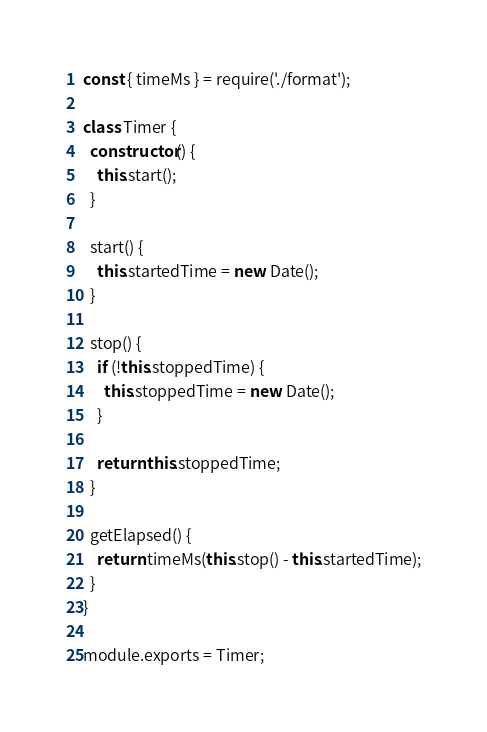Convert code to text. <code><loc_0><loc_0><loc_500><loc_500><_JavaScript_>const { timeMs } = require('./format');

class Timer {
  constructor() {
    this.start();
  }

  start() {
    this.startedTime = new Date();
  }

  stop() {
    if (!this.stoppedTime) {
      this.stoppedTime = new Date();
    }

    return this.stoppedTime;
  }

  getElapsed() {
    return timeMs(this.stop() - this.startedTime);
  }
}

module.exports = Timer;
</code> 